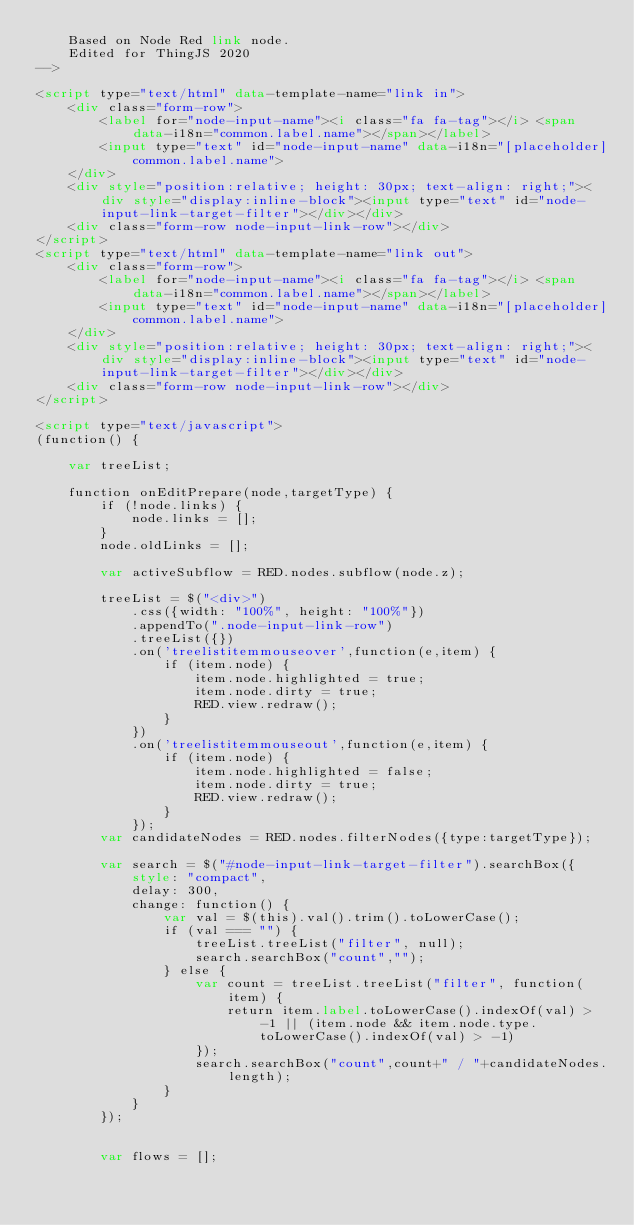<code> <loc_0><loc_0><loc_500><loc_500><_HTML_>    Based on Node Red link node.
    Edited for ThingJS 2020
-->

<script type="text/html" data-template-name="link in">
    <div class="form-row">
        <label for="node-input-name"><i class="fa fa-tag"></i> <span data-i18n="common.label.name"></span></label>
        <input type="text" id="node-input-name" data-i18n="[placeholder]common.label.name">
    </div>
    <div style="position:relative; height: 30px; text-align: right;"><div style="display:inline-block"><input type="text" id="node-input-link-target-filter"></div></div>
    <div class="form-row node-input-link-row"></div>
</script>
<script type="text/html" data-template-name="link out">
    <div class="form-row">
        <label for="node-input-name"><i class="fa fa-tag"></i> <span data-i18n="common.label.name"></span></label>
        <input type="text" id="node-input-name" data-i18n="[placeholder]common.label.name">
    </div>
    <div style="position:relative; height: 30px; text-align: right;"><div style="display:inline-block"><input type="text" id="node-input-link-target-filter"></div></div>
    <div class="form-row node-input-link-row"></div>
</script>

<script type="text/javascript">
(function() {

    var treeList;

    function onEditPrepare(node,targetType) {
        if (!node.links) {
            node.links = [];
        }
        node.oldLinks = [];

        var activeSubflow = RED.nodes.subflow(node.z);

        treeList = $("<div>")
            .css({width: "100%", height: "100%"})
            .appendTo(".node-input-link-row")
            .treeList({})
            .on('treelistitemmouseover',function(e,item) {
                if (item.node) {
                    item.node.highlighted = true;
                    item.node.dirty = true;
                    RED.view.redraw();
                }
            })
            .on('treelistitemmouseout',function(e,item) {
                if (item.node) {
                    item.node.highlighted = false;
                    item.node.dirty = true;
                    RED.view.redraw();
                }
            });
        var candidateNodes = RED.nodes.filterNodes({type:targetType});

        var search = $("#node-input-link-target-filter").searchBox({
            style: "compact",
            delay: 300,
            change: function() {
                var val = $(this).val().trim().toLowerCase();
                if (val === "") {
                    treeList.treeList("filter", null);
                    search.searchBox("count","");
                } else {
                    var count = treeList.treeList("filter", function(item) {
                        return item.label.toLowerCase().indexOf(val) > -1 || (item.node && item.node.type.toLowerCase().indexOf(val) > -1)
                    });
                    search.searchBox("count",count+" / "+candidateNodes.length);
                }
            }
        });


        var flows = [];</code> 